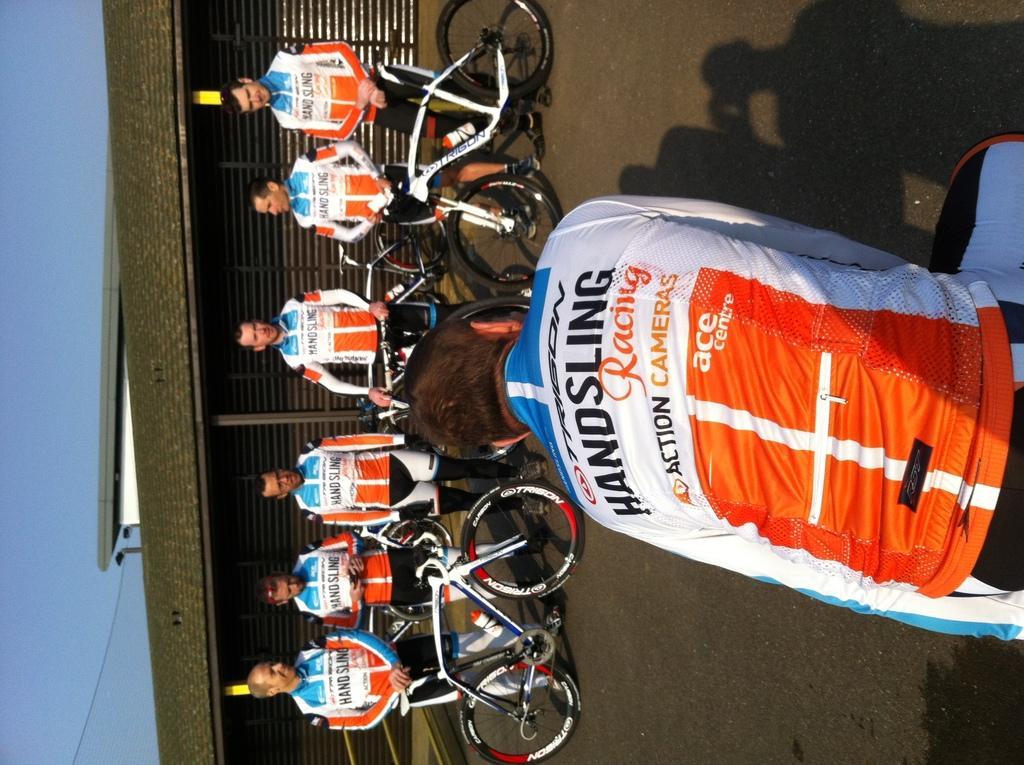Can you describe this image briefly? In the foreground, I can see bicycles and a group of people on the road. In the background, I can see buildings and the sky. This image taken, maybe during a day. 